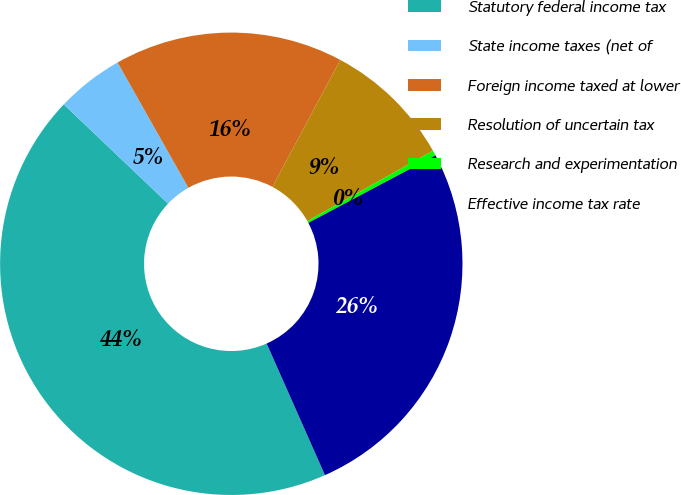<chart> <loc_0><loc_0><loc_500><loc_500><pie_chart><fcel>Statutory federal income tax<fcel>State income taxes (net of<fcel>Foreign income taxed at lower<fcel>Resolution of uncertain tax<fcel>Research and experimentation<fcel>Effective income tax rate<nl><fcel>43.74%<fcel>4.71%<fcel>16.0%<fcel>9.05%<fcel>0.37%<fcel>26.12%<nl></chart> 